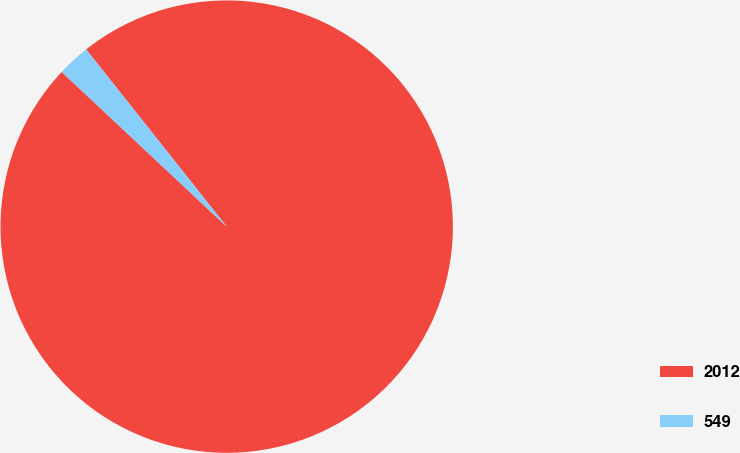Convert chart to OTSL. <chart><loc_0><loc_0><loc_500><loc_500><pie_chart><fcel>2012<fcel>549<nl><fcel>97.66%<fcel>2.34%<nl></chart> 